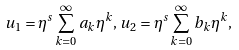Convert formula to latex. <formula><loc_0><loc_0><loc_500><loc_500>u _ { 1 } = \eta ^ { s } \sum _ { k = 0 } ^ { \infty } a _ { k } \eta ^ { k } , \, u _ { 2 } = \eta ^ { s } \sum _ { k = 0 } ^ { \infty } b _ { k } \eta ^ { k } ,</formula> 